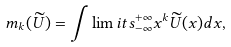Convert formula to latex. <formula><loc_0><loc_0><loc_500><loc_500>m _ { k } ( \widetilde { U } ) = \int \lim i t s _ { - \infty } ^ { + \infty } x ^ { k } \widetilde { U } ( x ) d x ,</formula> 